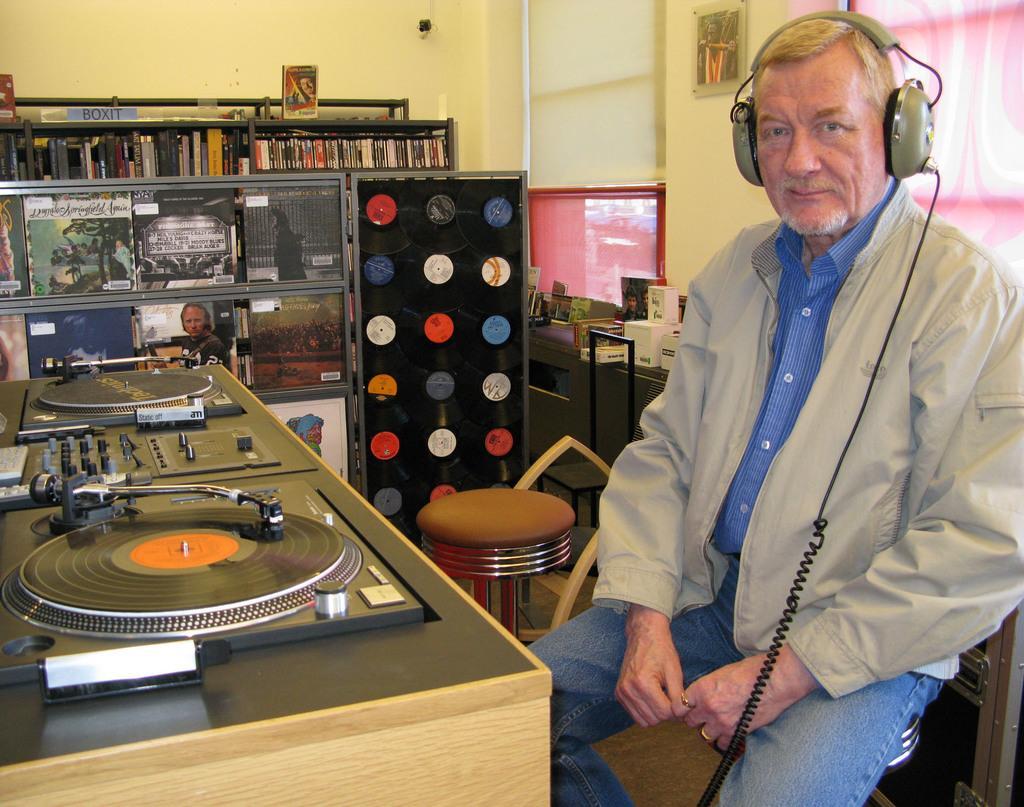Can you describe this image briefly? In this image there is a man sitting and wearing a headphone. In front of the man there is a musical instrument. In the background there are photo frame and there is a text written on it. On the right side there are windows and a frame on the wall and there is a stool. 